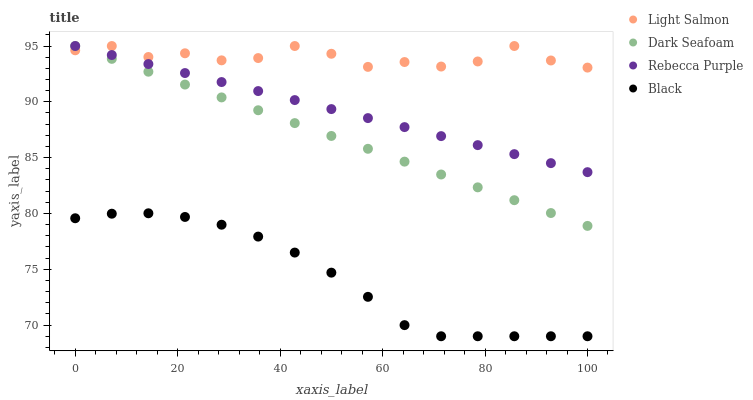Does Black have the minimum area under the curve?
Answer yes or no. Yes. Does Light Salmon have the maximum area under the curve?
Answer yes or no. Yes. Does Dark Seafoam have the minimum area under the curve?
Answer yes or no. No. Does Dark Seafoam have the maximum area under the curve?
Answer yes or no. No. Is Rebecca Purple the smoothest?
Answer yes or no. Yes. Is Light Salmon the roughest?
Answer yes or no. Yes. Is Black the smoothest?
Answer yes or no. No. Is Black the roughest?
Answer yes or no. No. Does Black have the lowest value?
Answer yes or no. Yes. Does Dark Seafoam have the lowest value?
Answer yes or no. No. Does Rebecca Purple have the highest value?
Answer yes or no. Yes. Does Black have the highest value?
Answer yes or no. No. Is Black less than Dark Seafoam?
Answer yes or no. Yes. Is Dark Seafoam greater than Black?
Answer yes or no. Yes. Does Dark Seafoam intersect Light Salmon?
Answer yes or no. Yes. Is Dark Seafoam less than Light Salmon?
Answer yes or no. No. Is Dark Seafoam greater than Light Salmon?
Answer yes or no. No. Does Black intersect Dark Seafoam?
Answer yes or no. No. 